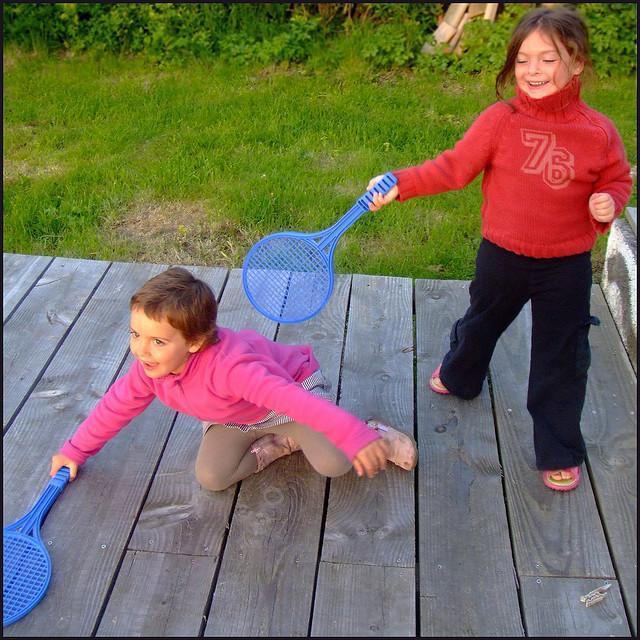How many rackets are pictured?
Give a very brief answer. 2. How many tennis rackets are there?
Give a very brief answer. 2. How many people are there?
Give a very brief answer. 2. How many stacks of phone books are visible?
Give a very brief answer. 0. 